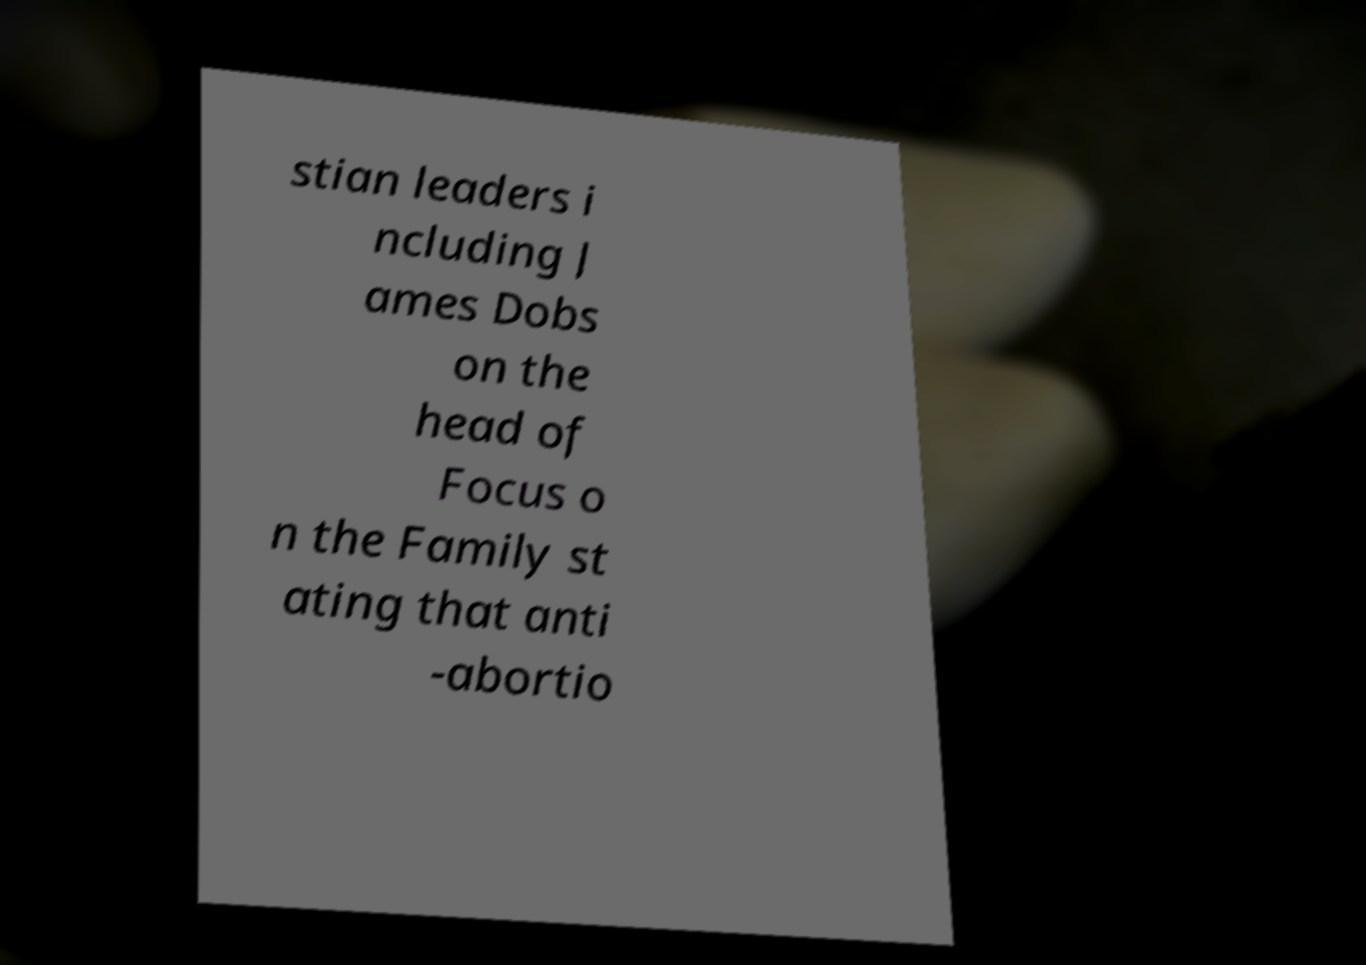Can you read and provide the text displayed in the image?This photo seems to have some interesting text. Can you extract and type it out for me? stian leaders i ncluding J ames Dobs on the head of Focus o n the Family st ating that anti -abortio 